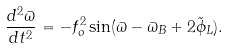<formula> <loc_0><loc_0><loc_500><loc_500>\frac { d ^ { 2 } \varpi } { d t ^ { 2 } } = - f _ { o } ^ { 2 } \sin ( \varpi - \varpi _ { B } + 2 \tilde { \phi } _ { L } ) .</formula> 